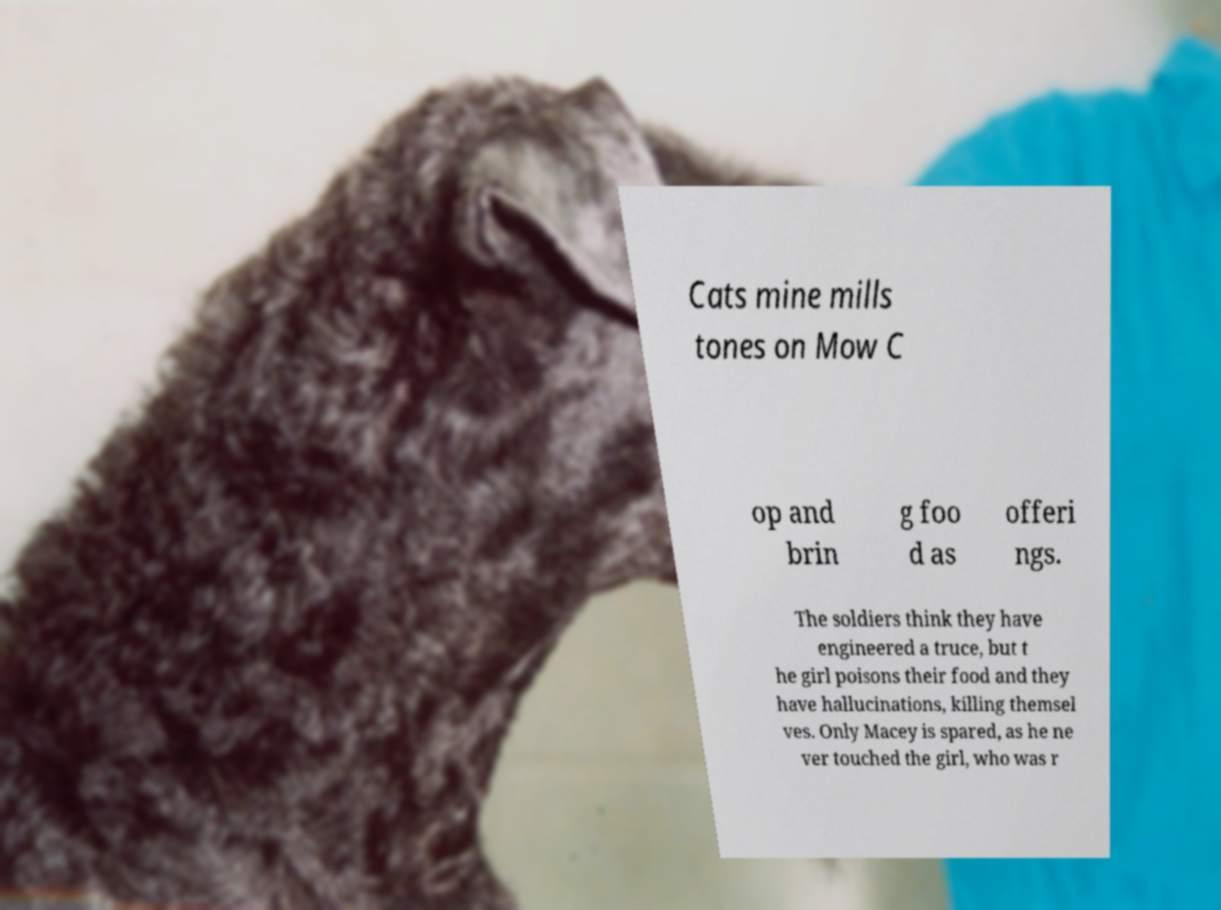Please read and relay the text visible in this image. What does it say? Cats mine mills tones on Mow C op and brin g foo d as offeri ngs. The soldiers think they have engineered a truce, but t he girl poisons their food and they have hallucinations, killing themsel ves. Only Macey is spared, as he ne ver touched the girl, who was r 